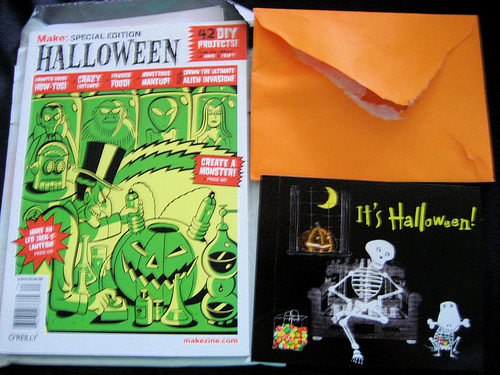<image>
Can you confirm if the book is above the book? No. The book is not positioned above the book. The vertical arrangement shows a different relationship. 